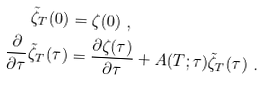<formula> <loc_0><loc_0><loc_500><loc_500>\tilde { \zeta } _ { T } ( 0 ) & = \zeta ( 0 ) \ , \\ \frac { \partial } { \partial \tau } \tilde { \zeta } _ { T } ( \tau ) & = \frac { \partial \zeta ( \tau ) } { \partial \tau } + A ( T ; \tau ) \tilde { \zeta } _ { T } ( \tau ) \ .</formula> 